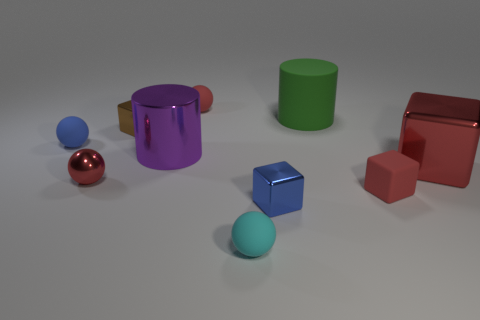Is there a tiny block that has the same color as the big metal cube? yes 